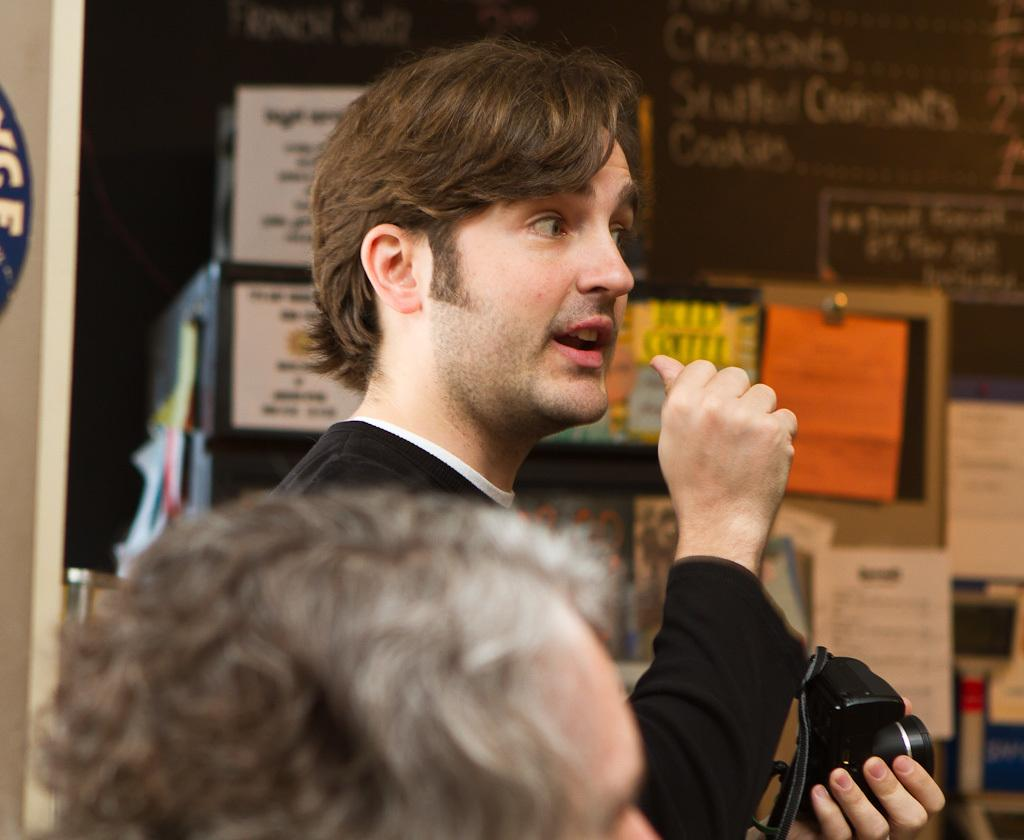What is the main subject of the image? The main subject of the image is a man. What is the man doing in the image? The man is standing in the image. What is the man holding in his hand? The man is holding a camera in his hand. Can you describe the background of the image? The image at the back (presumably the background of the scene) is a little blurry. What type of pain is the man experiencing in the image? There is no indication in the image that the man is experiencing any pain. What kind of van is parked next to the man in the image? There is no van present in the image. 